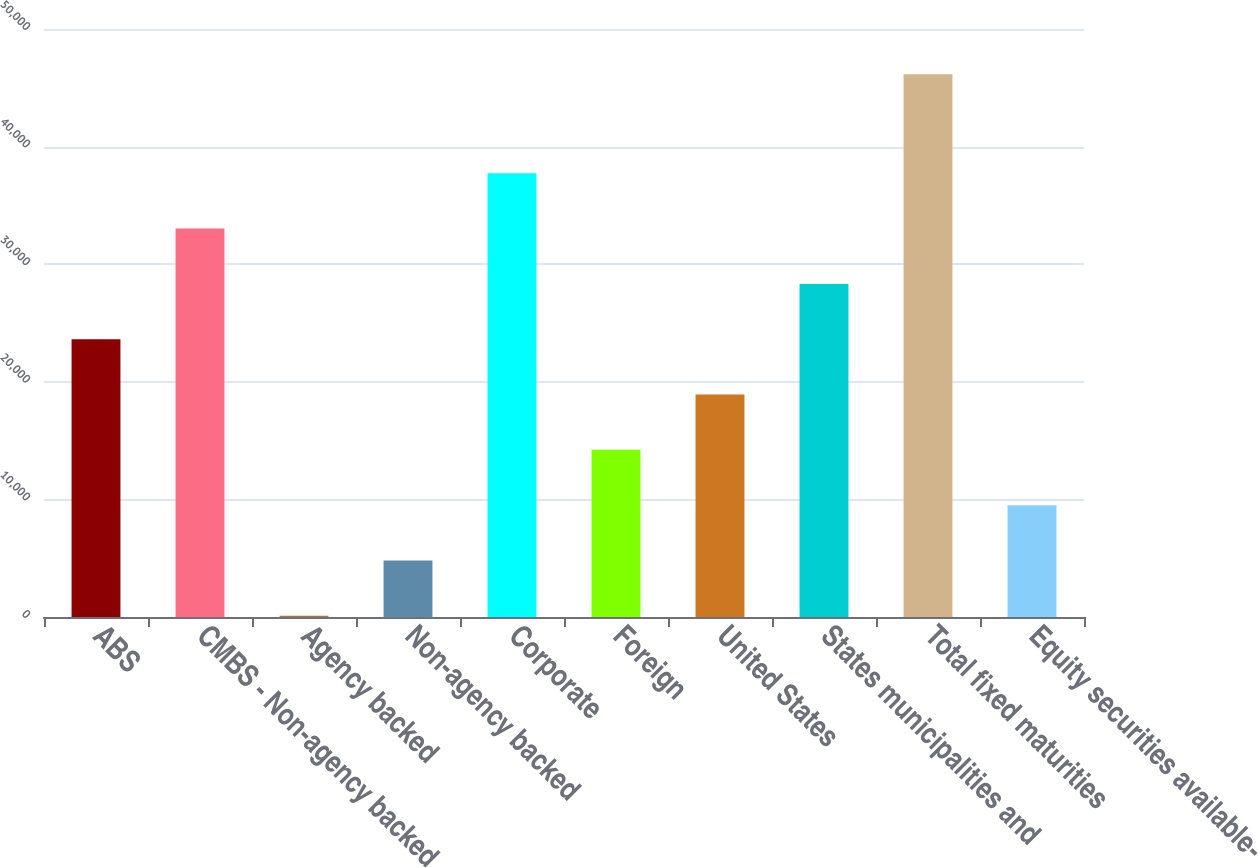Convert chart. <chart><loc_0><loc_0><loc_500><loc_500><bar_chart><fcel>ABS<fcel>CMBS - Non-agency backed<fcel>Agency backed<fcel>Non-agency backed<fcel>Corporate<fcel>Foreign<fcel>United States<fcel>States municipalities and<fcel>Total fixed maturities<fcel>Equity securities available-<nl><fcel>23620.5<fcel>33028.3<fcel>101<fcel>4804.9<fcel>37732.2<fcel>14212.7<fcel>18916.6<fcel>28324.4<fcel>46145<fcel>9508.8<nl></chart> 